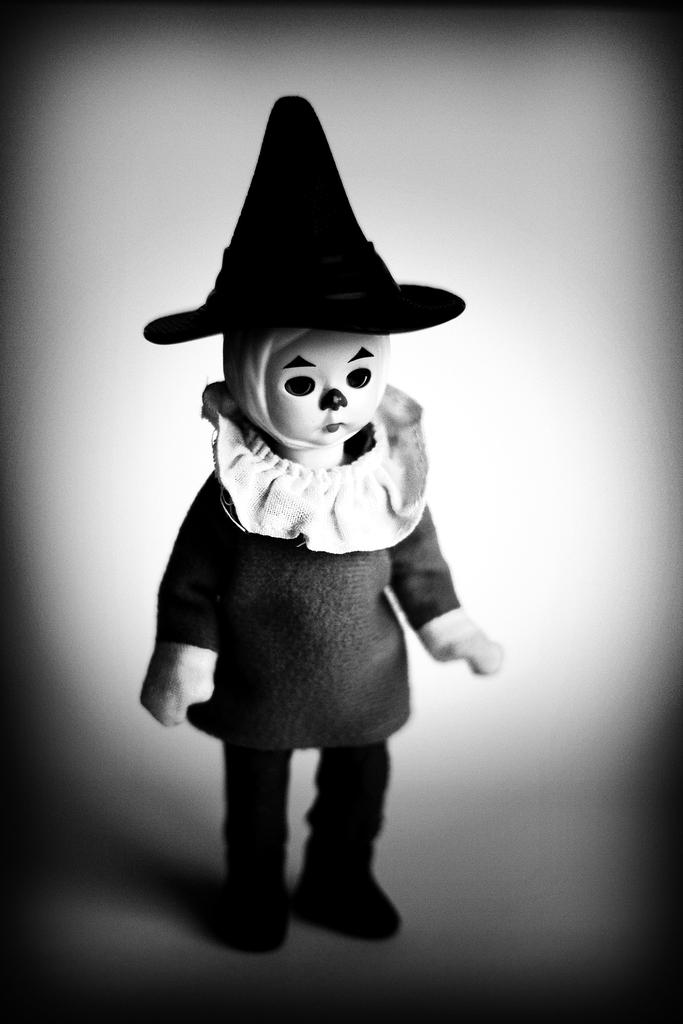What is the main subject in the middle of the image? There is a doll in the middle of the image. What other object can be seen in the image? There is a cap in the image. What is the color of the cap? The cap is black in color. How many bubbles are floating around the doll in the image? There are no bubbles present in the image. 